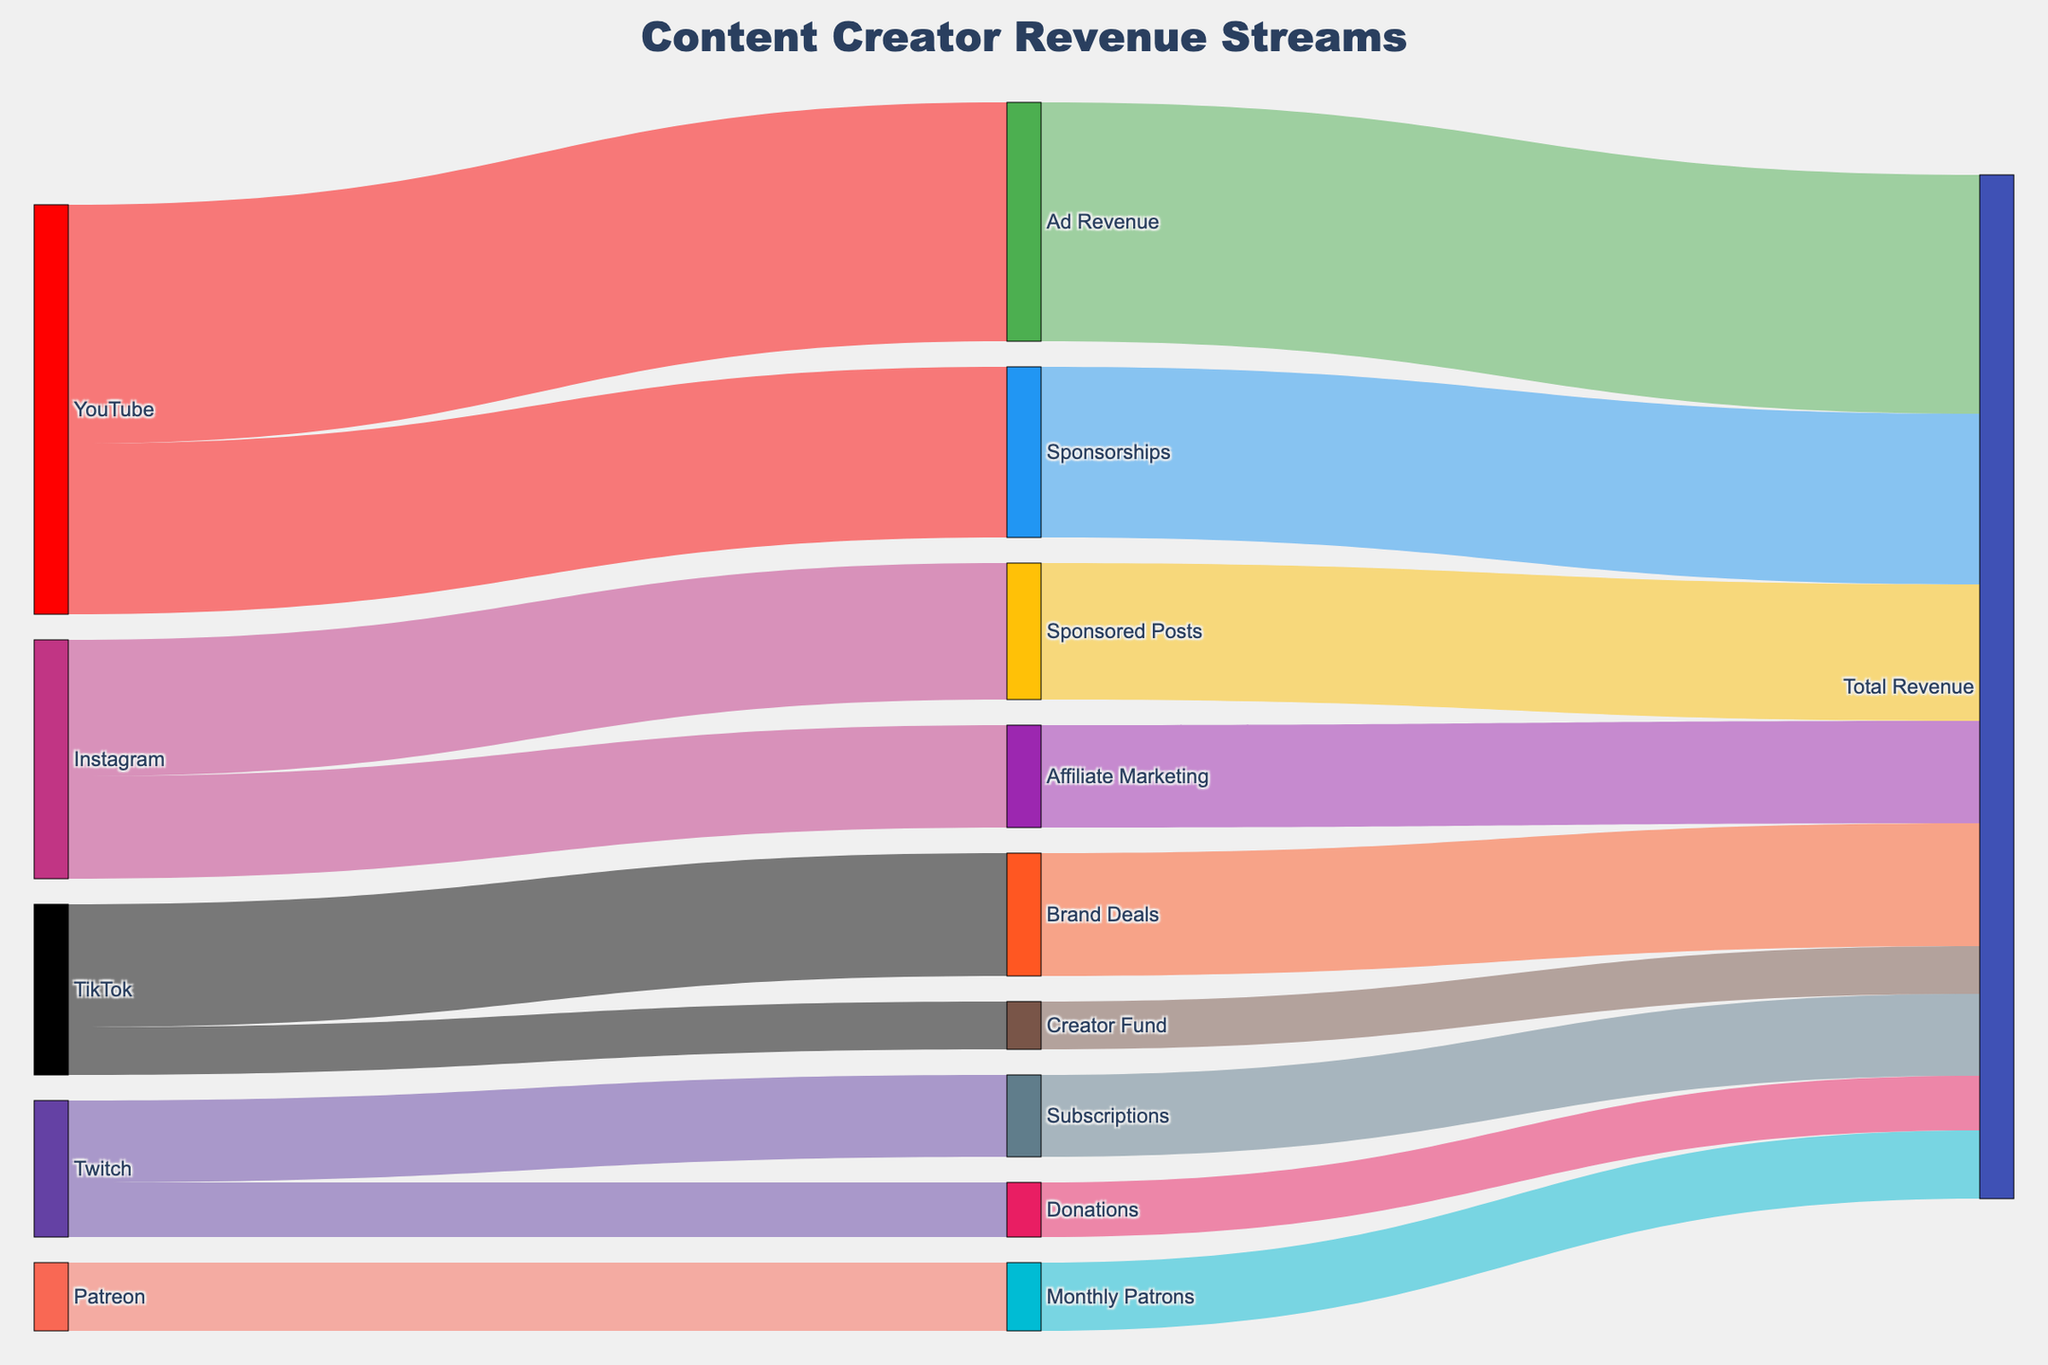What is the primary revenue stream from YouTube? To determine the primary revenue stream from YouTube, look at the connections from YouTube to its targets. The value associated with "Ad Revenue" is 35000, which is the largest.
Answer: Ad Revenue How much total revenue is generated by TikTok? Combine the values of the different revenue streams coming from TikTok. TikTok has "Brand Deals" valued at 18000 and "Creator Fund" valued at 7000. Adding these gives 18000 + 7000 = 25000.
Answer: 25000 Which platform contributes the most to Sponsored Posts? According to the figure, only Instagram contributes to Sponsored Posts, which has a value of 20000. Hence, Instagram is the only and hence the highest contributor.
Answer: Instagram How does the revenue from Subscriptions on Twitch compare to Donations on Twitch? Compare the values linked to Subscriptions and Donations on Twitch. Subscriptions are valued at 12000, while Donations are valued at 8000. 12000 is greater than 8000, so Subscriptions generate more.
Answer: Subscriptions What proportion of the total revenue is contributed by Ad Revenue alone? To find the proportion of Ad Revenue, divide the Ad Revenue value by the total revenue. The total revenue equals the sum of all streams: 35000 (Ad Revenue) + 25000 (Sponsorships) + 20000 (Sponsored Posts) + 15000 (Affiliate Marketing) + 18000 (Brand Deals) + 7000 (Creator Fund) + 12000 (Subscriptions) + 8000 (Donations) + 10000 (Monthly Patrons) = 150000. Therefore, 35000 / 150000 = 0.2333, or 23.33%.
Answer: 23.33% Which revenue stream has the smallest contribution and which platform does it come from? Identify the smallest value among all revenue streams. The smallest value listed is 7000 from the Creator Fund on TikTok.
Answer: Creator Fund, TikTok Among the social media platforms listed, which generates the highest total revenue and what is that amount? Add up the revenue from all sources for each platform to find the highest total. YouTube: 35000 + 25000 = 60000, Instagram: 20000 + 15000 = 35000, TikTok: 18000 + 7000 = 25000, Twitch: 12000 + 8000 = 20000, Patreon: 10000. YouTube has the highest total with 60000.
Answer: YouTube, 60000 